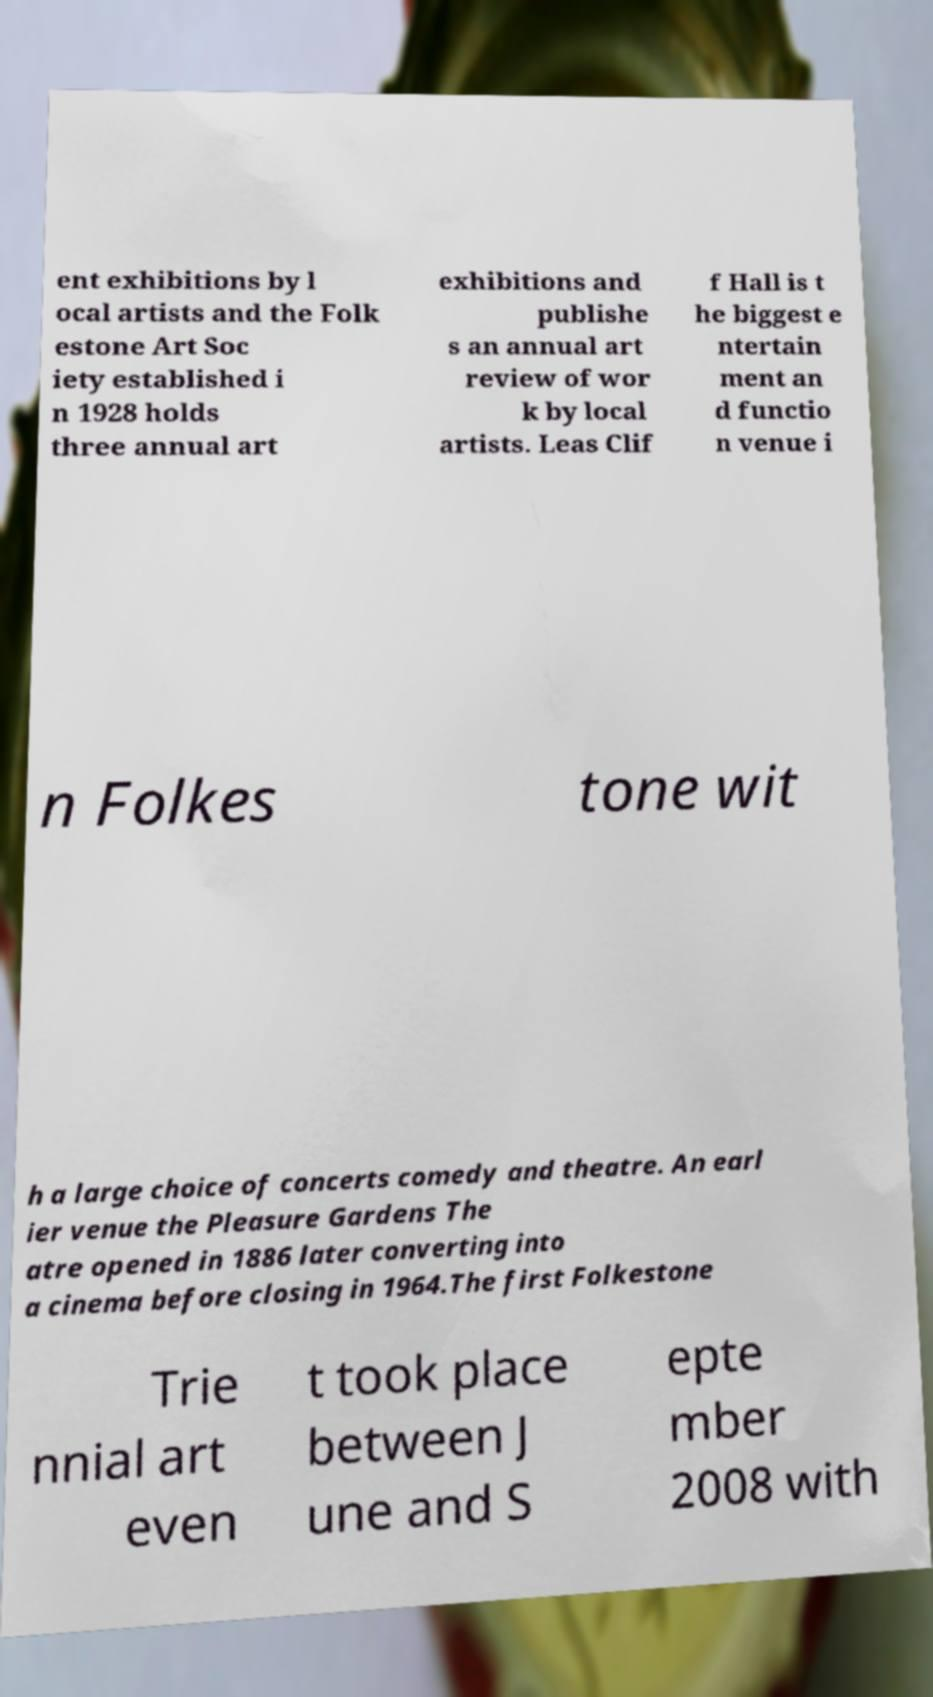Please read and relay the text visible in this image. What does it say? ent exhibitions by l ocal artists and the Folk estone Art Soc iety established i n 1928 holds three annual art exhibitions and publishe s an annual art review of wor k by local artists. Leas Clif f Hall is t he biggest e ntertain ment an d functio n venue i n Folkes tone wit h a large choice of concerts comedy and theatre. An earl ier venue the Pleasure Gardens The atre opened in 1886 later converting into a cinema before closing in 1964.The first Folkestone Trie nnial art even t took place between J une and S epte mber 2008 with 